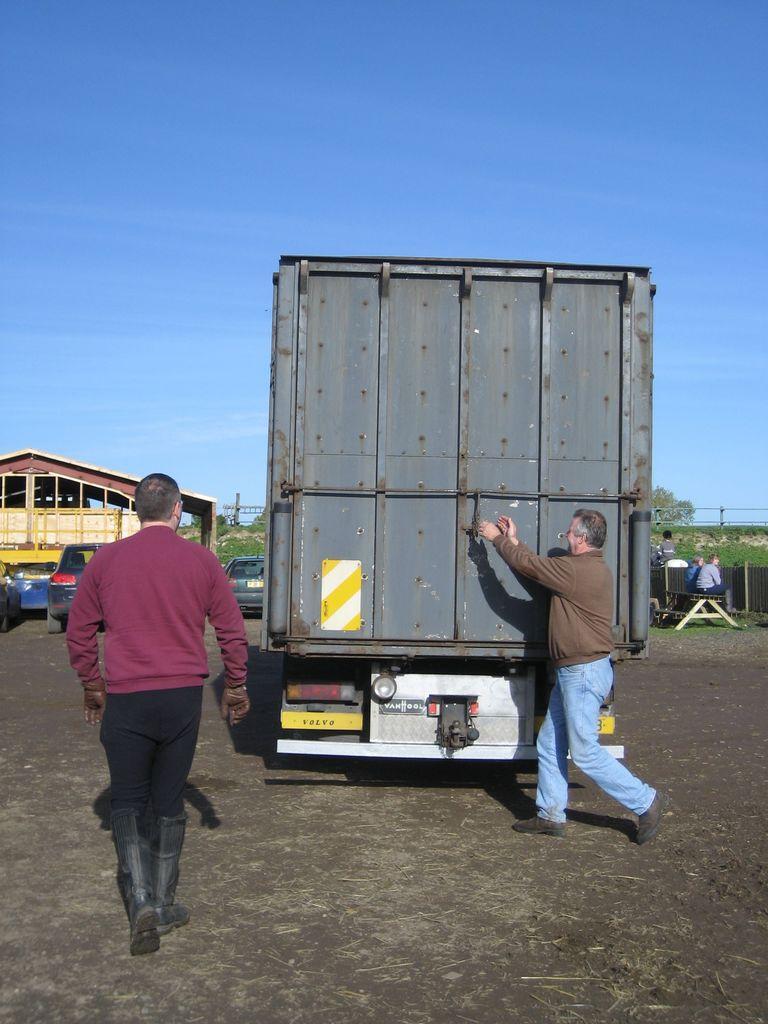Could you give a brief overview of what you see in this image? In this image we can see two persons are sitting on a bench at the right side of the image. There are few vehicles in the image. There is a tree in the image. There is clear and blue sky in the image. There is a grassy land in the image. 